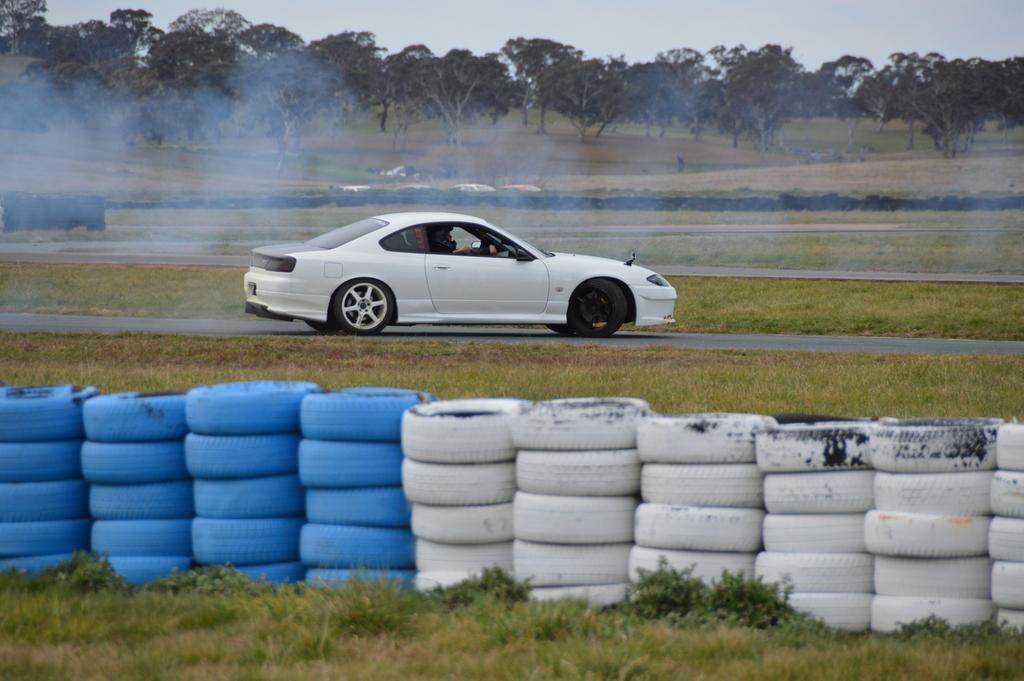Can you describe this image briefly? In this image there is a white car on the road. At the bottom there are tyres which are kept one above the other. In the background there are trees. On the left side there are blue tyres and on the right side there are white tyres. On the ground there is grass. 